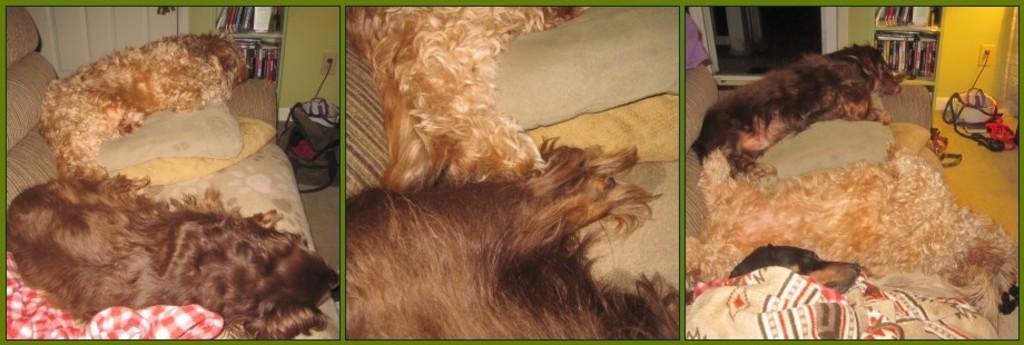Describe this image in one or two sentences. This is an edited image. This picture is the collage of three images. On the left side, we see two dogs are sleeping on the sofa. We see the pillows and a blanket in white and red color. Beside that, we see a bag and a green wall. Beside that, we see a rack in which books are placed and we see a white door. In the middle, we see the two dogs are sleeping on the sofa. On the right side, we see three dogs are sleeping on the sofa. We see the pillows and the blankets. Beside that, we see a green wall and a rack in which books are placed. We see the door and some objects are placed on the floor. 